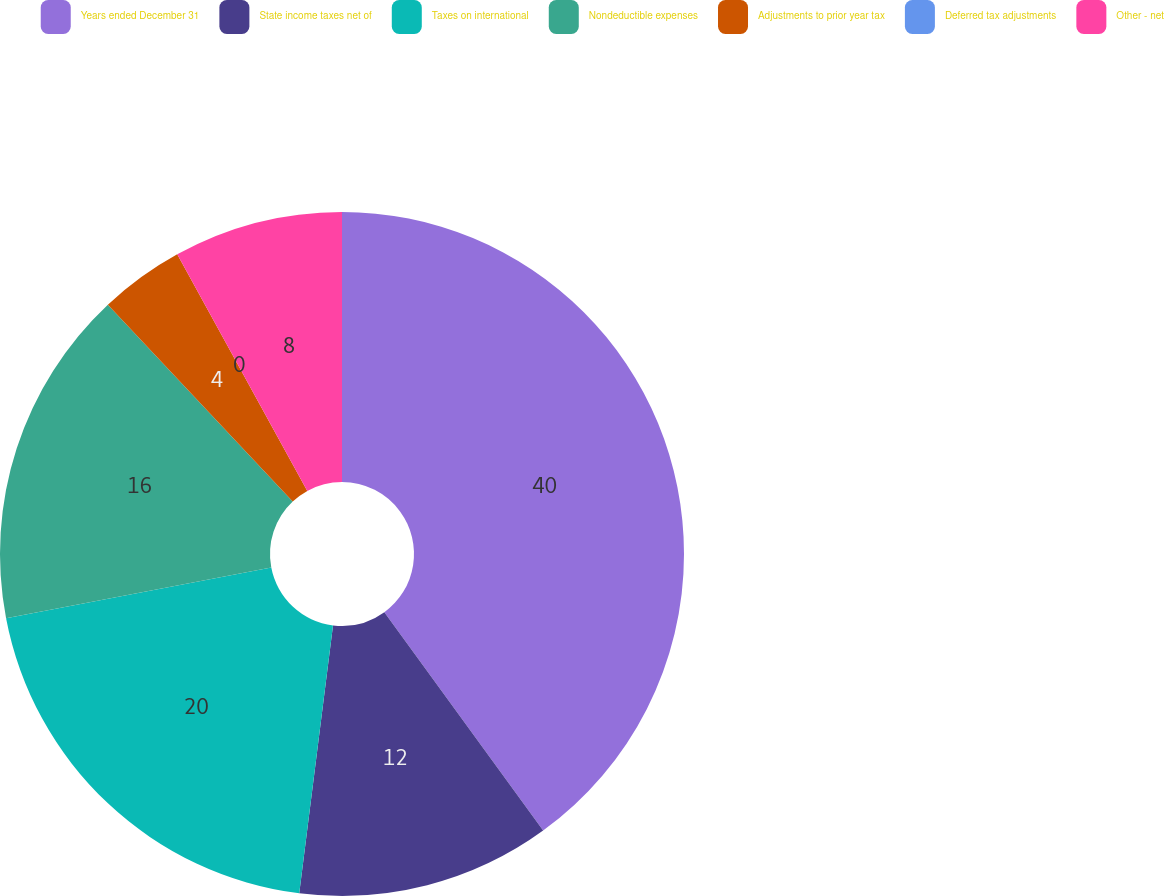Convert chart to OTSL. <chart><loc_0><loc_0><loc_500><loc_500><pie_chart><fcel>Years ended December 31<fcel>State income taxes net of<fcel>Taxes on international<fcel>Nondeductible expenses<fcel>Adjustments to prior year tax<fcel>Deferred tax adjustments<fcel>Other - net<nl><fcel>39.99%<fcel>12.0%<fcel>20.0%<fcel>16.0%<fcel>4.0%<fcel>0.0%<fcel>8.0%<nl></chart> 